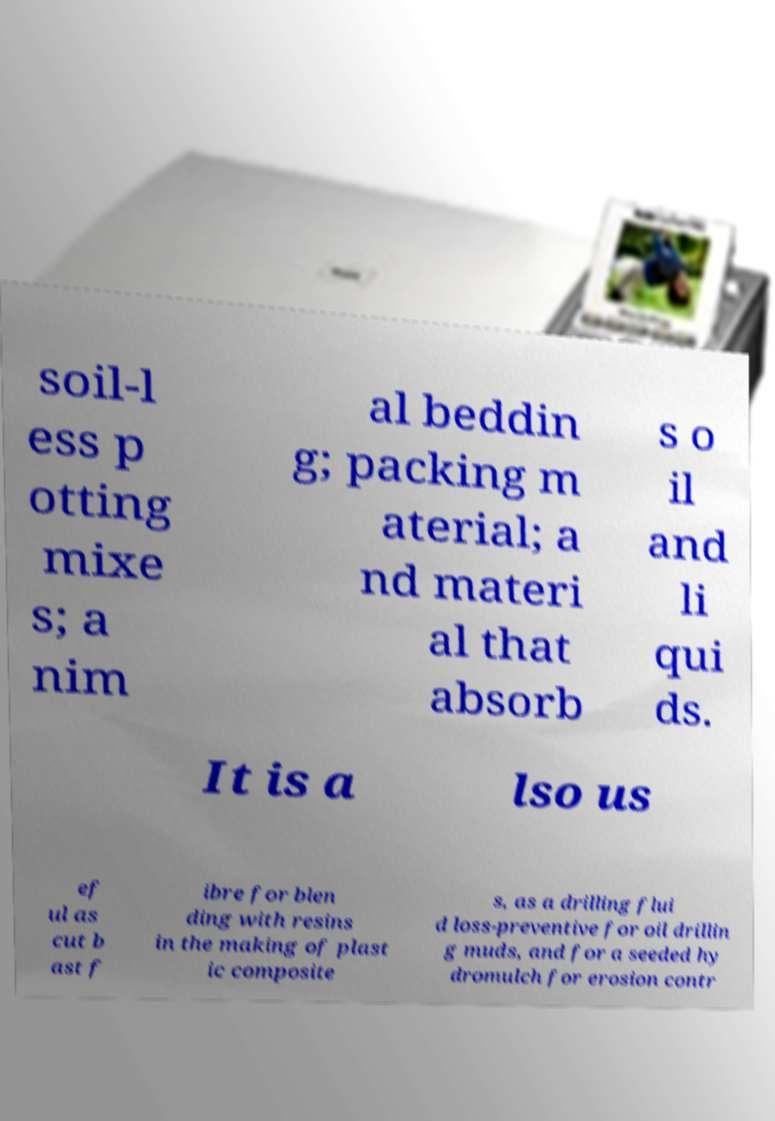Please read and relay the text visible in this image. What does it say? soil-l ess p otting mixe s; a nim al beddin g; packing m aterial; a nd materi al that absorb s o il and li qui ds. It is a lso us ef ul as cut b ast f ibre for blen ding with resins in the making of plast ic composite s, as a drilling flui d loss-preventive for oil drillin g muds, and for a seeded hy dromulch for erosion contr 